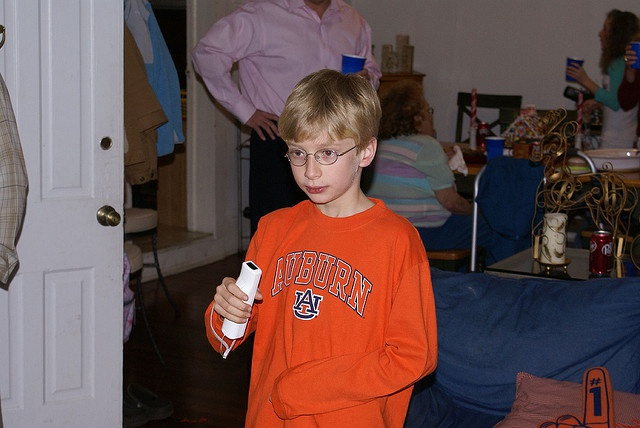Describe the objects in this image and their specific colors. I can see people in darkgray, red, brown, and black tones, couch in darkgray, navy, black, maroon, and brown tones, people in darkgray, gray, and black tones, people in darkgray, gray, black, maroon, and purple tones, and chair in darkgray, black, and gray tones in this image. 